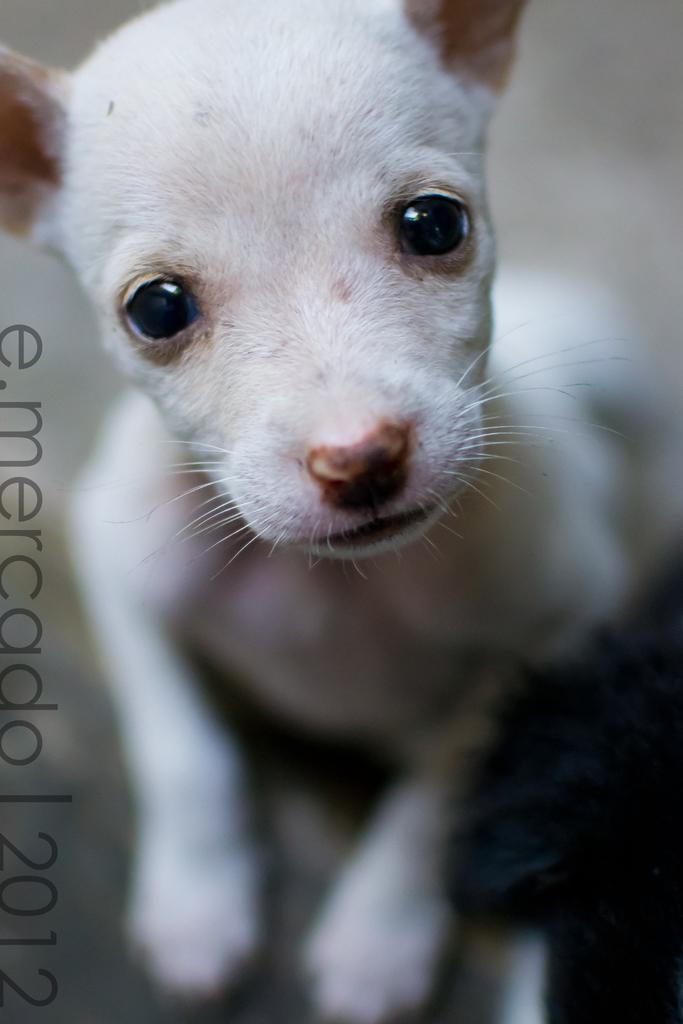Could you give a brief overview of what you see in this image? In this picture we can see an animal, some text and in the background it is blurry. 